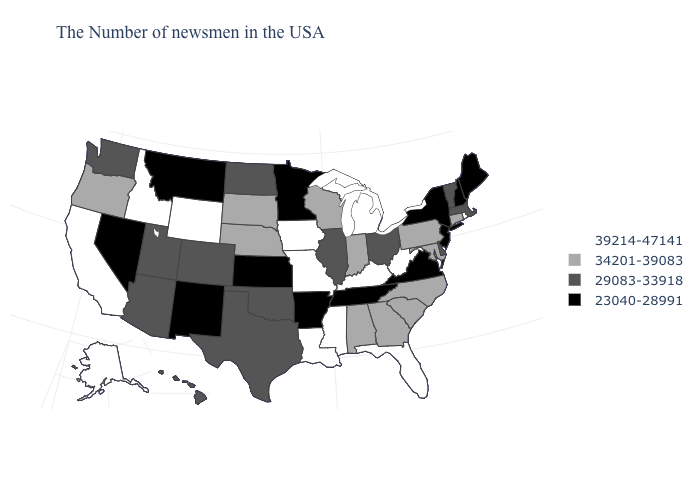Which states hav the highest value in the Northeast?
Answer briefly. Rhode Island. How many symbols are there in the legend?
Give a very brief answer. 4. What is the value of Hawaii?
Write a very short answer. 29083-33918. Name the states that have a value in the range 39214-47141?
Quick response, please. Rhode Island, West Virginia, Florida, Michigan, Kentucky, Mississippi, Louisiana, Missouri, Iowa, Wyoming, Idaho, California, Alaska. Name the states that have a value in the range 29083-33918?
Concise answer only. Massachusetts, Vermont, Delaware, Ohio, Illinois, Oklahoma, Texas, North Dakota, Colorado, Utah, Arizona, Washington, Hawaii. Does the first symbol in the legend represent the smallest category?
Concise answer only. No. Among the states that border Maryland , does Pennsylvania have the highest value?
Quick response, please. No. What is the value of New Jersey?
Keep it brief. 23040-28991. What is the value of Delaware?
Answer briefly. 29083-33918. What is the value of Maine?
Write a very short answer. 23040-28991. What is the lowest value in the West?
Quick response, please. 23040-28991. Name the states that have a value in the range 23040-28991?
Answer briefly. Maine, New Hampshire, New York, New Jersey, Virginia, Tennessee, Arkansas, Minnesota, Kansas, New Mexico, Montana, Nevada. Name the states that have a value in the range 23040-28991?
Give a very brief answer. Maine, New Hampshire, New York, New Jersey, Virginia, Tennessee, Arkansas, Minnesota, Kansas, New Mexico, Montana, Nevada. Which states have the highest value in the USA?
Answer briefly. Rhode Island, West Virginia, Florida, Michigan, Kentucky, Mississippi, Louisiana, Missouri, Iowa, Wyoming, Idaho, California, Alaska. Does Rhode Island have the highest value in the USA?
Short answer required. Yes. 